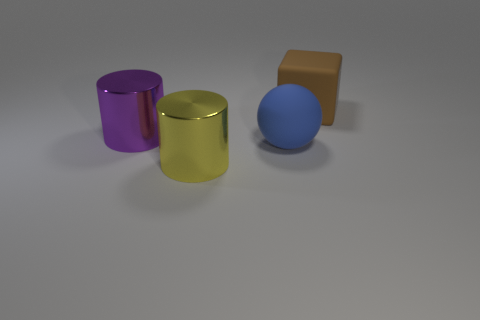What is the shape of the rubber object right of the big rubber object to the left of the object right of the ball?
Ensure brevity in your answer.  Cube. Are there any blue cubes that have the same material as the large yellow cylinder?
Keep it short and to the point. No. There is a metallic thing in front of the big blue sphere; does it have the same color as the large object that is right of the large blue matte thing?
Ensure brevity in your answer.  No. Are there fewer purple metallic objects that are behind the brown cube than big cyan cylinders?
Offer a terse response. No. What number of objects are large metal objects or big things in front of the big ball?
Provide a short and direct response. 2. What color is the object that is the same material as the large brown block?
Your answer should be compact. Blue. What number of objects are either yellow cylinders or blue things?
Offer a very short reply. 2. What is the color of the ball that is the same size as the cube?
Provide a succinct answer. Blue. What number of objects are big metal objects that are behind the yellow shiny cylinder or brown blocks?
Your response must be concise. 2. How many other things are the same size as the purple cylinder?
Provide a short and direct response. 3. 